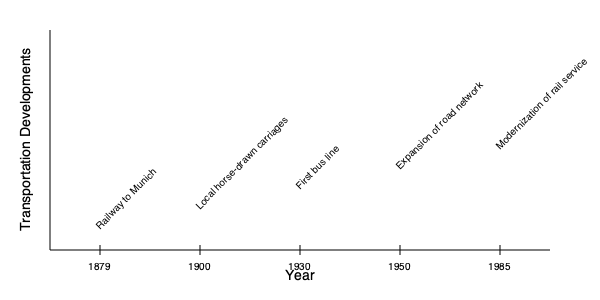According to the timeline, which transportation development in Murnau am Staffelsee occurred closest to the midpoint of the 20th century? To answer this question, we need to follow these steps:

1. Identify the midpoint of the 20th century:
   - The 20th century spans from 1901 to 2000
   - The midpoint would be 1950

2. Examine the transportation developments shown on the timeline:
   - 1879: Railway to Munich
   - 1900: Local horse-drawn carriages
   - 1930: First bus line
   - 1950: Expansion of road network
   - 1985: Modernization of rail service

3. Compare the dates to find which is closest to 1950:
   - 1879 is 71 years before 1950
   - 1900 is 50 years before 1950
   - 1930 is 20 years before 1950
   - 1950 is exactly at the midpoint
   - 1985 is 35 years after 1950

4. Conclude that the expansion of the road network in 1950 is the development that occurred closest to the midpoint of the 20th century.
Answer: Expansion of road network 